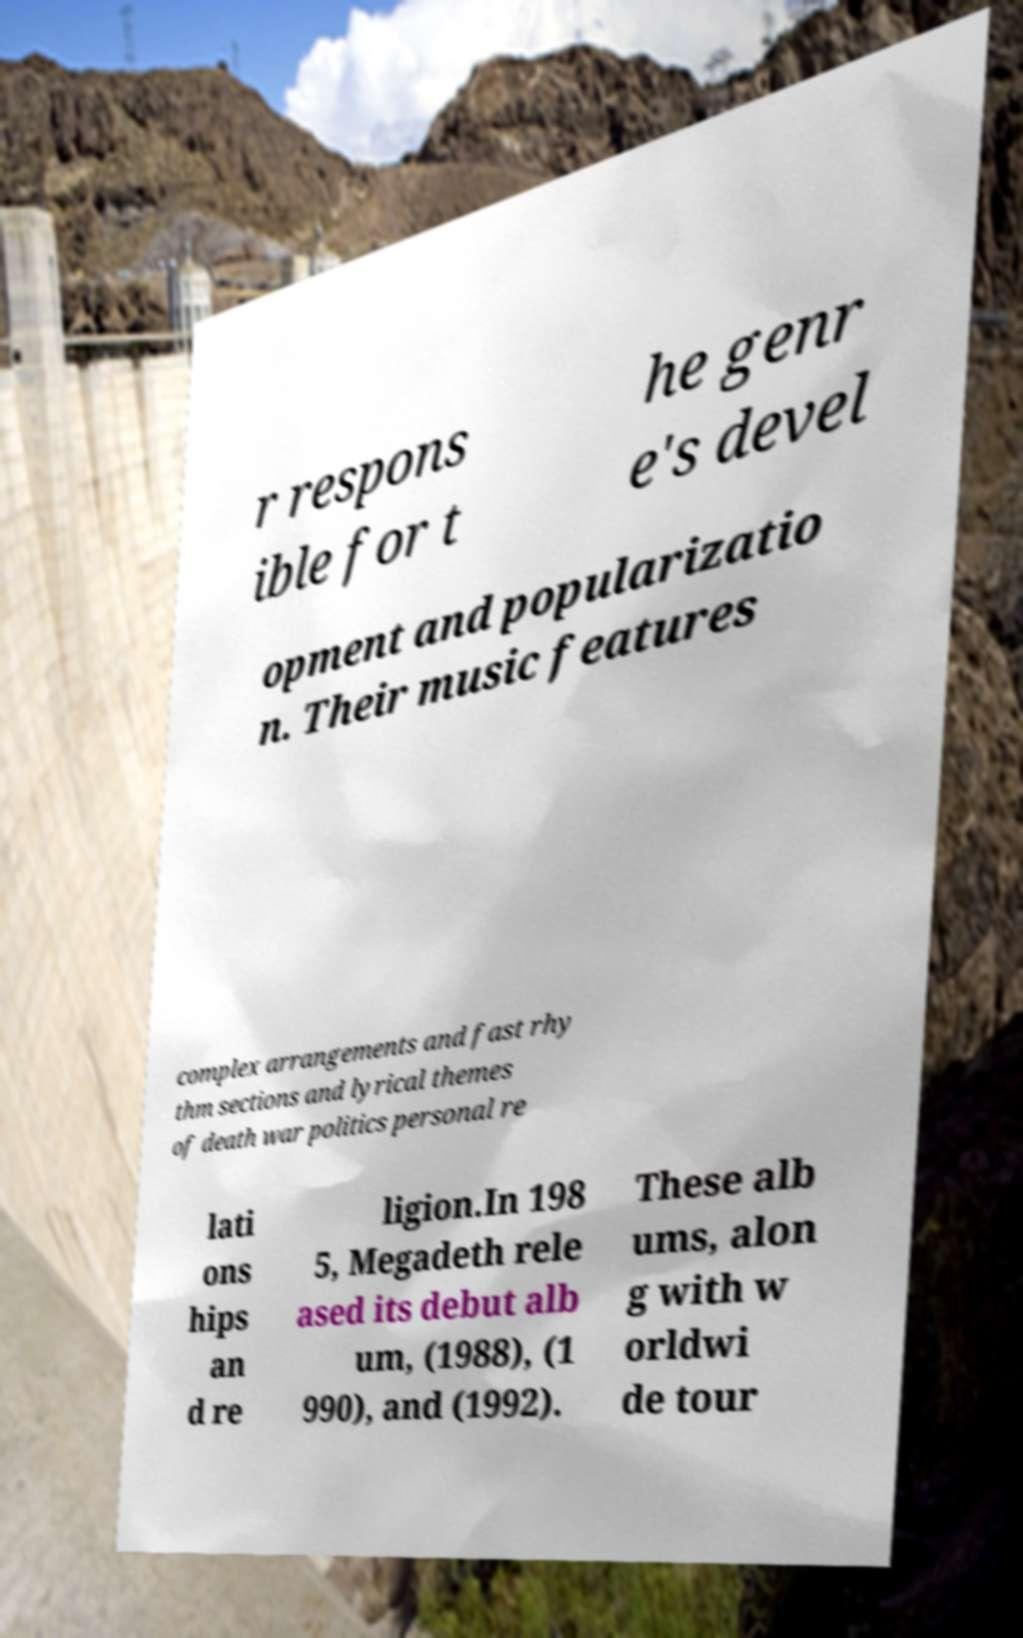Can you read and provide the text displayed in the image?This photo seems to have some interesting text. Can you extract and type it out for me? r respons ible for t he genr e's devel opment and popularizatio n. Their music features complex arrangements and fast rhy thm sections and lyrical themes of death war politics personal re lati ons hips an d re ligion.In 198 5, Megadeth rele ased its debut alb um, (1988), (1 990), and (1992). These alb ums, alon g with w orldwi de tour 